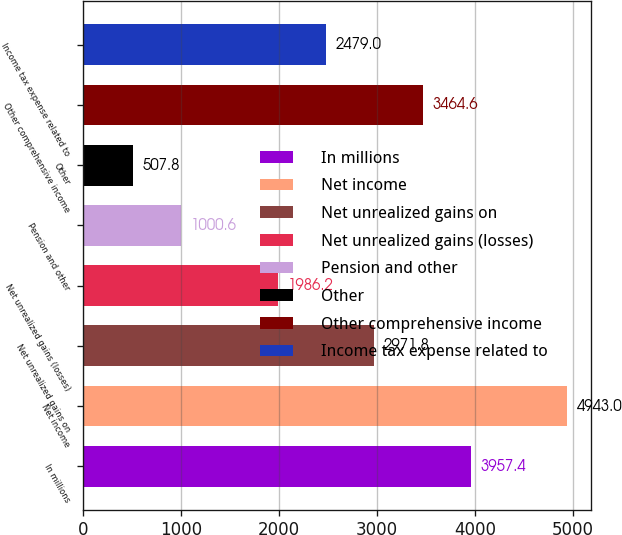Convert chart to OTSL. <chart><loc_0><loc_0><loc_500><loc_500><bar_chart><fcel>In millions<fcel>Net income<fcel>Net unrealized gains on<fcel>Net unrealized gains (losses)<fcel>Pension and other<fcel>Other<fcel>Other comprehensive income<fcel>Income tax expense related to<nl><fcel>3957.4<fcel>4943<fcel>2971.8<fcel>1986.2<fcel>1000.6<fcel>507.8<fcel>3464.6<fcel>2479<nl></chart> 